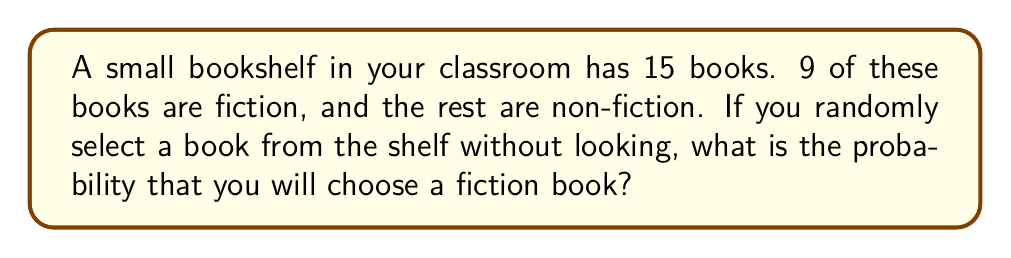Show me your answer to this math problem. Let's approach this step-by-step:

1. First, we need to identify the important information:
   - Total number of books: 15
   - Number of fiction books: 9
   - Number of non-fiction books: 15 - 9 = 6

2. The probability of an event is calculated by dividing the number of favorable outcomes by the total number of possible outcomes:

   $$ P(\text{event}) = \frac{\text{favorable outcomes}}{\text{total possible outcomes}} $$

3. In this case:
   - Favorable outcomes: selecting a fiction book (9 ways to do this)
   - Total possible outcomes: selecting any book (15 ways to do this)

4. Let's plug these numbers into our probability formula:

   $$ P(\text{fiction}) = \frac{9}{15} $$

5. We can simplify this fraction:

   $$ P(\text{fiction}) = \frac{9}{15} = \frac{3}{5} = 0.6 $$

6. To convert to a percentage, multiply by 100:

   $$ 0.6 \times 100 = 60\% $$

Thus, the probability of selecting a fiction book is $\frac{3}{5}$ or 60%.
Answer: $\frac{3}{5}$ or 60% 